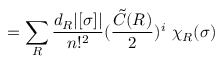<formula> <loc_0><loc_0><loc_500><loc_500>= \sum _ { R } \frac { d _ { R } | [ \sigma ] | } { n ! ^ { 2 } } ( \frac { { \tilde { C } } ( R ) } { 2 } ) ^ { i } \ \chi _ { R } ( \sigma )</formula> 